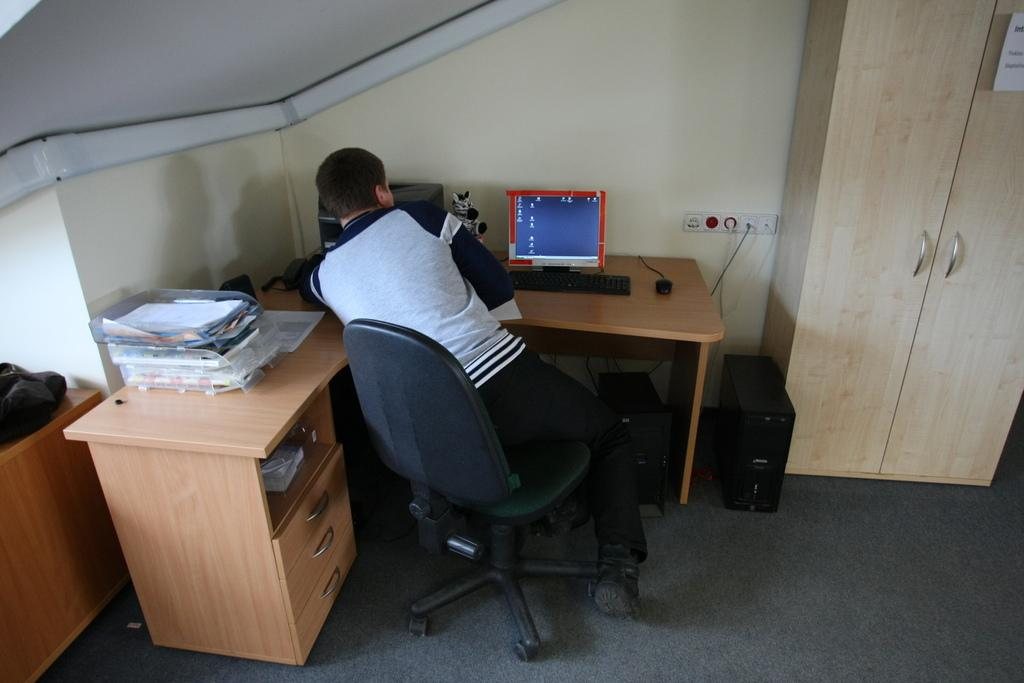Who is present in the image? There is a man in the image. What is the man doing in the image? The man is sitting on a chair in the image. What objects are present in the image related to the man's activity? There is a table, a system (computer), a keyboard, and a mouse present in the image. What other furniture is visible in the image? There is a cupboard in the image. What is the main component of the computer system in the image? A CPU is present in the image. What type of lettuce is being exchanged between the man and the ice in the image? There is no lettuce or ice present in the image. The man is using a computer system, which does not involve exchanging lettuce or ice. 